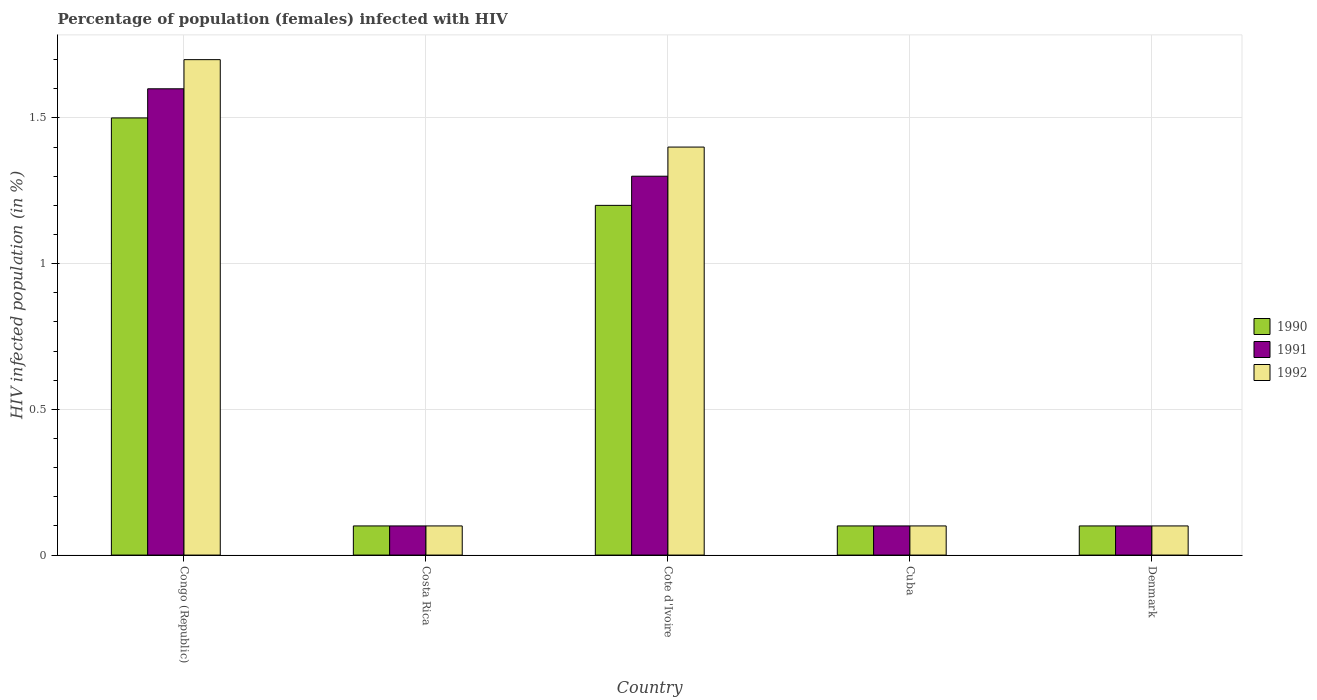Are the number of bars per tick equal to the number of legend labels?
Keep it short and to the point. Yes. How many bars are there on the 1st tick from the left?
Give a very brief answer. 3. What is the label of the 1st group of bars from the left?
Offer a very short reply. Congo (Republic). In how many cases, is the number of bars for a given country not equal to the number of legend labels?
Give a very brief answer. 0. What is the percentage of HIV infected female population in 1991 in Cuba?
Make the answer very short. 0.1. In which country was the percentage of HIV infected female population in 1990 maximum?
Keep it short and to the point. Congo (Republic). In which country was the percentage of HIV infected female population in 1991 minimum?
Make the answer very short. Costa Rica. What is the total percentage of HIV infected female population in 1992 in the graph?
Offer a very short reply. 3.4. What is the difference between the percentage of HIV infected female population in 1990 in Congo (Republic) and that in Cuba?
Provide a succinct answer. 1.4. What is the difference between the percentage of HIV infected female population in 1990 in Denmark and the percentage of HIV infected female population in 1992 in Congo (Republic)?
Make the answer very short. -1.6. What is the average percentage of HIV infected female population in 1991 per country?
Make the answer very short. 0.64. What is the difference between the percentage of HIV infected female population of/in 1991 and percentage of HIV infected female population of/in 1992 in Cuba?
Keep it short and to the point. 0. In how many countries, is the percentage of HIV infected female population in 1992 greater than 1 %?
Ensure brevity in your answer.  2. What is the difference between the highest and the second highest percentage of HIV infected female population in 1990?
Make the answer very short. -1.4. In how many countries, is the percentage of HIV infected female population in 1990 greater than the average percentage of HIV infected female population in 1990 taken over all countries?
Offer a terse response. 2. What does the 3rd bar from the right in Congo (Republic) represents?
Provide a succinct answer. 1990. How many bars are there?
Ensure brevity in your answer.  15. How many countries are there in the graph?
Offer a very short reply. 5. What is the difference between two consecutive major ticks on the Y-axis?
Your answer should be compact. 0.5. Are the values on the major ticks of Y-axis written in scientific E-notation?
Your answer should be compact. No. Does the graph contain any zero values?
Keep it short and to the point. No. Does the graph contain grids?
Provide a short and direct response. Yes. Where does the legend appear in the graph?
Keep it short and to the point. Center right. What is the title of the graph?
Your answer should be compact. Percentage of population (females) infected with HIV. What is the label or title of the Y-axis?
Provide a short and direct response. HIV infected population (in %). What is the HIV infected population (in %) of 1990 in Congo (Republic)?
Make the answer very short. 1.5. What is the HIV infected population (in %) of 1992 in Congo (Republic)?
Your answer should be compact. 1.7. What is the HIV infected population (in %) of 1990 in Costa Rica?
Offer a terse response. 0.1. What is the HIV infected population (in %) of 1991 in Cote d'Ivoire?
Keep it short and to the point. 1.3. What is the HIV infected population (in %) in 1991 in Cuba?
Offer a very short reply. 0.1. What is the HIV infected population (in %) of 1992 in Cuba?
Your answer should be very brief. 0.1. What is the HIV infected population (in %) of 1990 in Denmark?
Offer a very short reply. 0.1. What is the HIV infected population (in %) of 1992 in Denmark?
Offer a terse response. 0.1. Across all countries, what is the minimum HIV infected population (in %) in 1992?
Offer a very short reply. 0.1. What is the total HIV infected population (in %) of 1990 in the graph?
Offer a very short reply. 3. What is the total HIV infected population (in %) of 1992 in the graph?
Keep it short and to the point. 3.4. What is the difference between the HIV infected population (in %) in 1991 in Congo (Republic) and that in Costa Rica?
Make the answer very short. 1.5. What is the difference between the HIV infected population (in %) in 1992 in Congo (Republic) and that in Costa Rica?
Provide a succinct answer. 1.6. What is the difference between the HIV infected population (in %) in 1992 in Congo (Republic) and that in Cote d'Ivoire?
Provide a short and direct response. 0.3. What is the difference between the HIV infected population (in %) in 1990 in Congo (Republic) and that in Cuba?
Offer a very short reply. 1.4. What is the difference between the HIV infected population (in %) of 1990 in Congo (Republic) and that in Denmark?
Ensure brevity in your answer.  1.4. What is the difference between the HIV infected population (in %) of 1991 in Congo (Republic) and that in Denmark?
Offer a terse response. 1.5. What is the difference between the HIV infected population (in %) in 1992 in Congo (Republic) and that in Denmark?
Your answer should be very brief. 1.6. What is the difference between the HIV infected population (in %) of 1990 in Costa Rica and that in Cote d'Ivoire?
Keep it short and to the point. -1.1. What is the difference between the HIV infected population (in %) in 1992 in Costa Rica and that in Cote d'Ivoire?
Ensure brevity in your answer.  -1.3. What is the difference between the HIV infected population (in %) in 1990 in Costa Rica and that in Cuba?
Provide a short and direct response. 0. What is the difference between the HIV infected population (in %) in 1991 in Costa Rica and that in Denmark?
Give a very brief answer. 0. What is the difference between the HIV infected population (in %) of 1990 in Cote d'Ivoire and that in Cuba?
Offer a terse response. 1.1. What is the difference between the HIV infected population (in %) of 1992 in Cote d'Ivoire and that in Cuba?
Ensure brevity in your answer.  1.3. What is the difference between the HIV infected population (in %) in 1991 in Cote d'Ivoire and that in Denmark?
Offer a terse response. 1.2. What is the difference between the HIV infected population (in %) of 1992 in Cote d'Ivoire and that in Denmark?
Provide a succinct answer. 1.3. What is the difference between the HIV infected population (in %) in 1991 in Cuba and that in Denmark?
Provide a succinct answer. 0. What is the difference between the HIV infected population (in %) in 1992 in Cuba and that in Denmark?
Offer a terse response. 0. What is the difference between the HIV infected population (in %) in 1990 in Congo (Republic) and the HIV infected population (in %) in 1991 in Costa Rica?
Keep it short and to the point. 1.4. What is the difference between the HIV infected population (in %) of 1990 in Congo (Republic) and the HIV infected population (in %) of 1992 in Costa Rica?
Give a very brief answer. 1.4. What is the difference between the HIV infected population (in %) in 1991 in Congo (Republic) and the HIV infected population (in %) in 1992 in Cote d'Ivoire?
Keep it short and to the point. 0.2. What is the difference between the HIV infected population (in %) of 1990 in Congo (Republic) and the HIV infected population (in %) of 1991 in Cuba?
Offer a terse response. 1.4. What is the difference between the HIV infected population (in %) of 1990 in Congo (Republic) and the HIV infected population (in %) of 1992 in Cuba?
Offer a very short reply. 1.4. What is the difference between the HIV infected population (in %) of 1991 in Congo (Republic) and the HIV infected population (in %) of 1992 in Cuba?
Your answer should be compact. 1.5. What is the difference between the HIV infected population (in %) in 1990 in Congo (Republic) and the HIV infected population (in %) in 1991 in Denmark?
Make the answer very short. 1.4. What is the difference between the HIV infected population (in %) in 1990 in Congo (Republic) and the HIV infected population (in %) in 1992 in Denmark?
Your answer should be compact. 1.4. What is the difference between the HIV infected population (in %) of 1990 in Costa Rica and the HIV infected population (in %) of 1991 in Cote d'Ivoire?
Your answer should be very brief. -1.2. What is the difference between the HIV infected population (in %) of 1990 in Costa Rica and the HIV infected population (in %) of 1992 in Cote d'Ivoire?
Ensure brevity in your answer.  -1.3. What is the difference between the HIV infected population (in %) of 1990 in Costa Rica and the HIV infected population (in %) of 1992 in Cuba?
Offer a very short reply. 0. What is the difference between the HIV infected population (in %) in 1990 in Cote d'Ivoire and the HIV infected population (in %) in 1992 in Cuba?
Your response must be concise. 1.1. What is the difference between the HIV infected population (in %) of 1990 in Cote d'Ivoire and the HIV infected population (in %) of 1991 in Denmark?
Give a very brief answer. 1.1. What is the difference between the HIV infected population (in %) of 1991 in Cote d'Ivoire and the HIV infected population (in %) of 1992 in Denmark?
Your response must be concise. 1.2. What is the difference between the HIV infected population (in %) of 1990 in Cuba and the HIV infected population (in %) of 1992 in Denmark?
Your response must be concise. 0. What is the average HIV infected population (in %) of 1990 per country?
Provide a succinct answer. 0.6. What is the average HIV infected population (in %) in 1991 per country?
Your answer should be very brief. 0.64. What is the average HIV infected population (in %) in 1992 per country?
Provide a succinct answer. 0.68. What is the difference between the HIV infected population (in %) of 1991 and HIV infected population (in %) of 1992 in Congo (Republic)?
Offer a terse response. -0.1. What is the difference between the HIV infected population (in %) in 1990 and HIV infected population (in %) in 1991 in Costa Rica?
Your answer should be very brief. 0. What is the difference between the HIV infected population (in %) in 1990 and HIV infected population (in %) in 1992 in Costa Rica?
Your answer should be very brief. 0. What is the difference between the HIV infected population (in %) of 1990 and HIV infected population (in %) of 1991 in Cote d'Ivoire?
Your answer should be very brief. -0.1. What is the difference between the HIV infected population (in %) of 1990 and HIV infected population (in %) of 1991 in Cuba?
Make the answer very short. 0. What is the difference between the HIV infected population (in %) of 1990 and HIV infected population (in %) of 1991 in Denmark?
Your response must be concise. 0. What is the ratio of the HIV infected population (in %) of 1990 in Congo (Republic) to that in Costa Rica?
Your answer should be compact. 15. What is the ratio of the HIV infected population (in %) in 1990 in Congo (Republic) to that in Cote d'Ivoire?
Keep it short and to the point. 1.25. What is the ratio of the HIV infected population (in %) in 1991 in Congo (Republic) to that in Cote d'Ivoire?
Provide a succinct answer. 1.23. What is the ratio of the HIV infected population (in %) of 1992 in Congo (Republic) to that in Cote d'Ivoire?
Make the answer very short. 1.21. What is the ratio of the HIV infected population (in %) of 1990 in Congo (Republic) to that in Cuba?
Give a very brief answer. 15. What is the ratio of the HIV infected population (in %) of 1991 in Congo (Republic) to that in Cuba?
Offer a very short reply. 16. What is the ratio of the HIV infected population (in %) of 1990 in Congo (Republic) to that in Denmark?
Give a very brief answer. 15. What is the ratio of the HIV infected population (in %) of 1991 in Congo (Republic) to that in Denmark?
Give a very brief answer. 16. What is the ratio of the HIV infected population (in %) of 1992 in Congo (Republic) to that in Denmark?
Offer a terse response. 17. What is the ratio of the HIV infected population (in %) of 1990 in Costa Rica to that in Cote d'Ivoire?
Make the answer very short. 0.08. What is the ratio of the HIV infected population (in %) in 1991 in Costa Rica to that in Cote d'Ivoire?
Provide a short and direct response. 0.08. What is the ratio of the HIV infected population (in %) of 1992 in Costa Rica to that in Cote d'Ivoire?
Your answer should be compact. 0.07. What is the ratio of the HIV infected population (in %) of 1990 in Costa Rica to that in Denmark?
Keep it short and to the point. 1. What is the ratio of the HIV infected population (in %) of 1991 in Costa Rica to that in Denmark?
Keep it short and to the point. 1. What is the ratio of the HIV infected population (in %) of 1990 in Cote d'Ivoire to that in Cuba?
Keep it short and to the point. 12. What is the ratio of the HIV infected population (in %) of 1992 in Cote d'Ivoire to that in Cuba?
Your answer should be compact. 14. What is the ratio of the HIV infected population (in %) of 1990 in Cote d'Ivoire to that in Denmark?
Provide a succinct answer. 12. What is the ratio of the HIV infected population (in %) in 1991 in Cote d'Ivoire to that in Denmark?
Provide a short and direct response. 13. What is the ratio of the HIV infected population (in %) of 1991 in Cuba to that in Denmark?
Keep it short and to the point. 1. What is the difference between the highest and the second highest HIV infected population (in %) of 1991?
Offer a very short reply. 0.3. What is the difference between the highest and the second highest HIV infected population (in %) of 1992?
Provide a succinct answer. 0.3. What is the difference between the highest and the lowest HIV infected population (in %) of 1990?
Give a very brief answer. 1.4. 